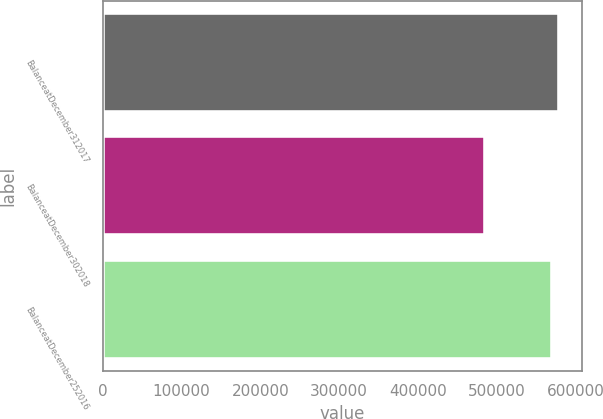<chart> <loc_0><loc_0><loc_500><loc_500><bar_chart><fcel>BalanceatDecember312017<fcel>BalanceatDecember302018<fcel>BalanceatDecember252016<nl><fcel>579273<fcel>485881<fcel>570555<nl></chart> 